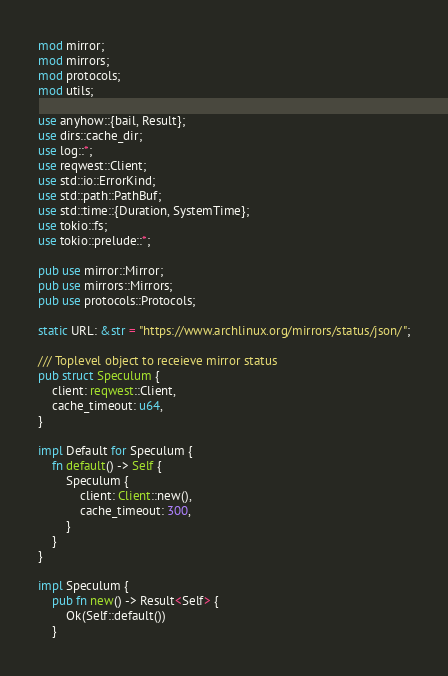<code> <loc_0><loc_0><loc_500><loc_500><_Rust_>mod mirror;
mod mirrors;
mod protocols;
mod utils;

use anyhow::{bail, Result};
use dirs::cache_dir;
use log::*;
use reqwest::Client;
use std::io::ErrorKind;
use std::path::PathBuf;
use std::time::{Duration, SystemTime};
use tokio::fs;
use tokio::prelude::*;

pub use mirror::Mirror;
pub use mirrors::Mirrors;
pub use protocols::Protocols;

static URL: &str = "https://www.archlinux.org/mirrors/status/json/";

/// Toplevel object to receieve mirror status
pub struct Speculum {
    client: reqwest::Client,
    cache_timeout: u64,
}

impl Default for Speculum {
    fn default() -> Self {
        Speculum {
            client: Client::new(),
            cache_timeout: 300,
        }
    }
}

impl Speculum {
    pub fn new() -> Result<Self> {
        Ok(Self::default())
    }
</code> 